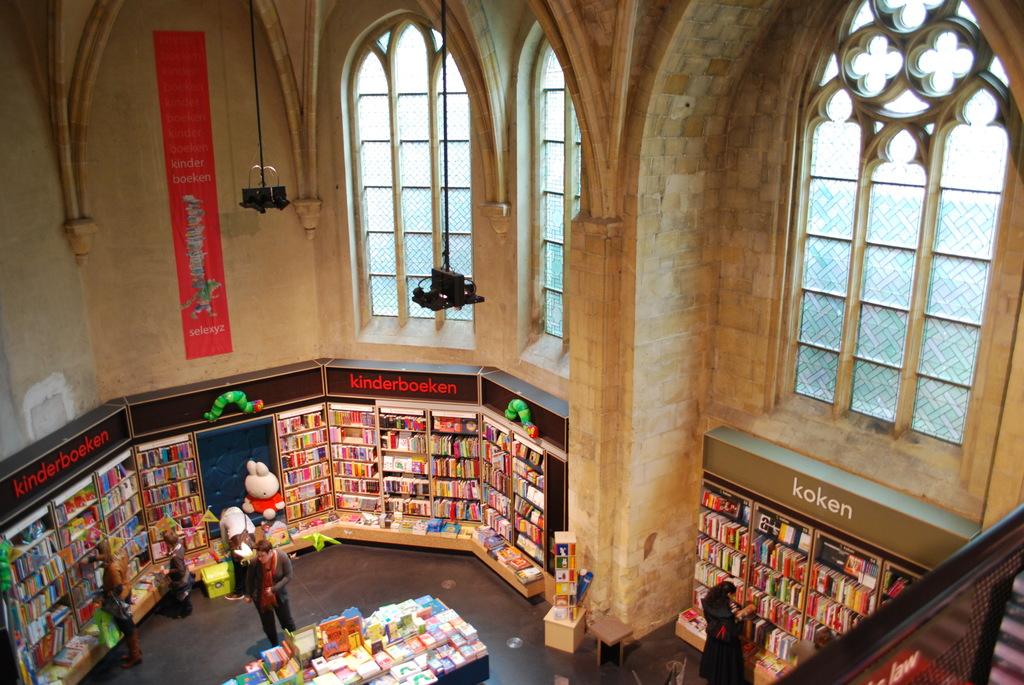What does the right panel read?
Give a very brief answer. Koken. 